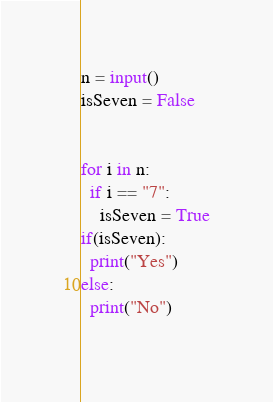<code> <loc_0><loc_0><loc_500><loc_500><_Python_>n = input()
isSeven = False


for i in n:
  if i == "7":
    isSeven = True
if(isSeven):
  print("Yes")
else:
  print("No")
    </code> 